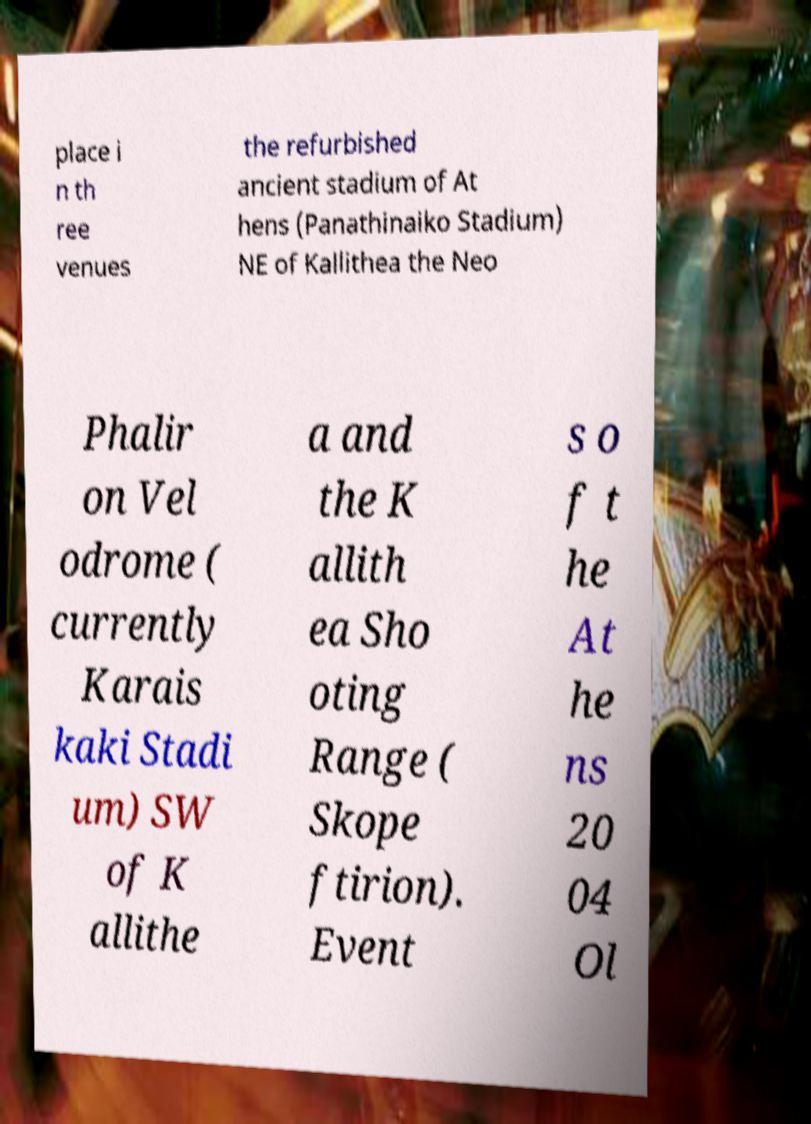Can you accurately transcribe the text from the provided image for me? place i n th ree venues the refurbished ancient stadium of At hens (Panathinaiko Stadium) NE of Kallithea the Neo Phalir on Vel odrome ( currently Karais kaki Stadi um) SW of K allithe a and the K allith ea Sho oting Range ( Skope ftirion). Event s o f t he At he ns 20 04 Ol 